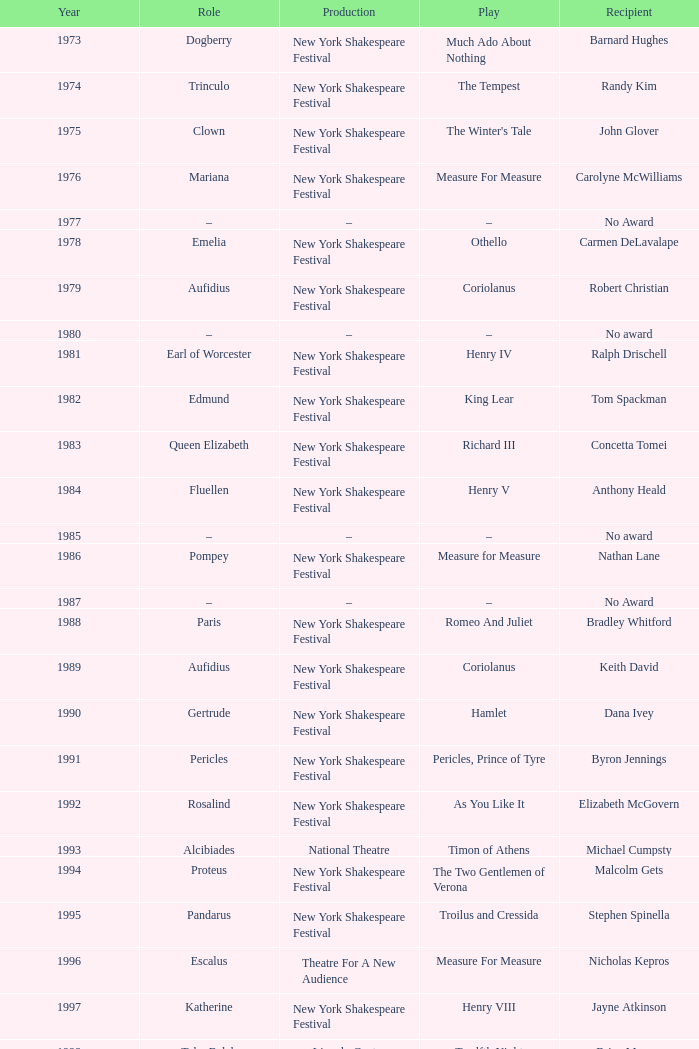Name the recipientof the year for 1976 Carolyne McWilliams. 